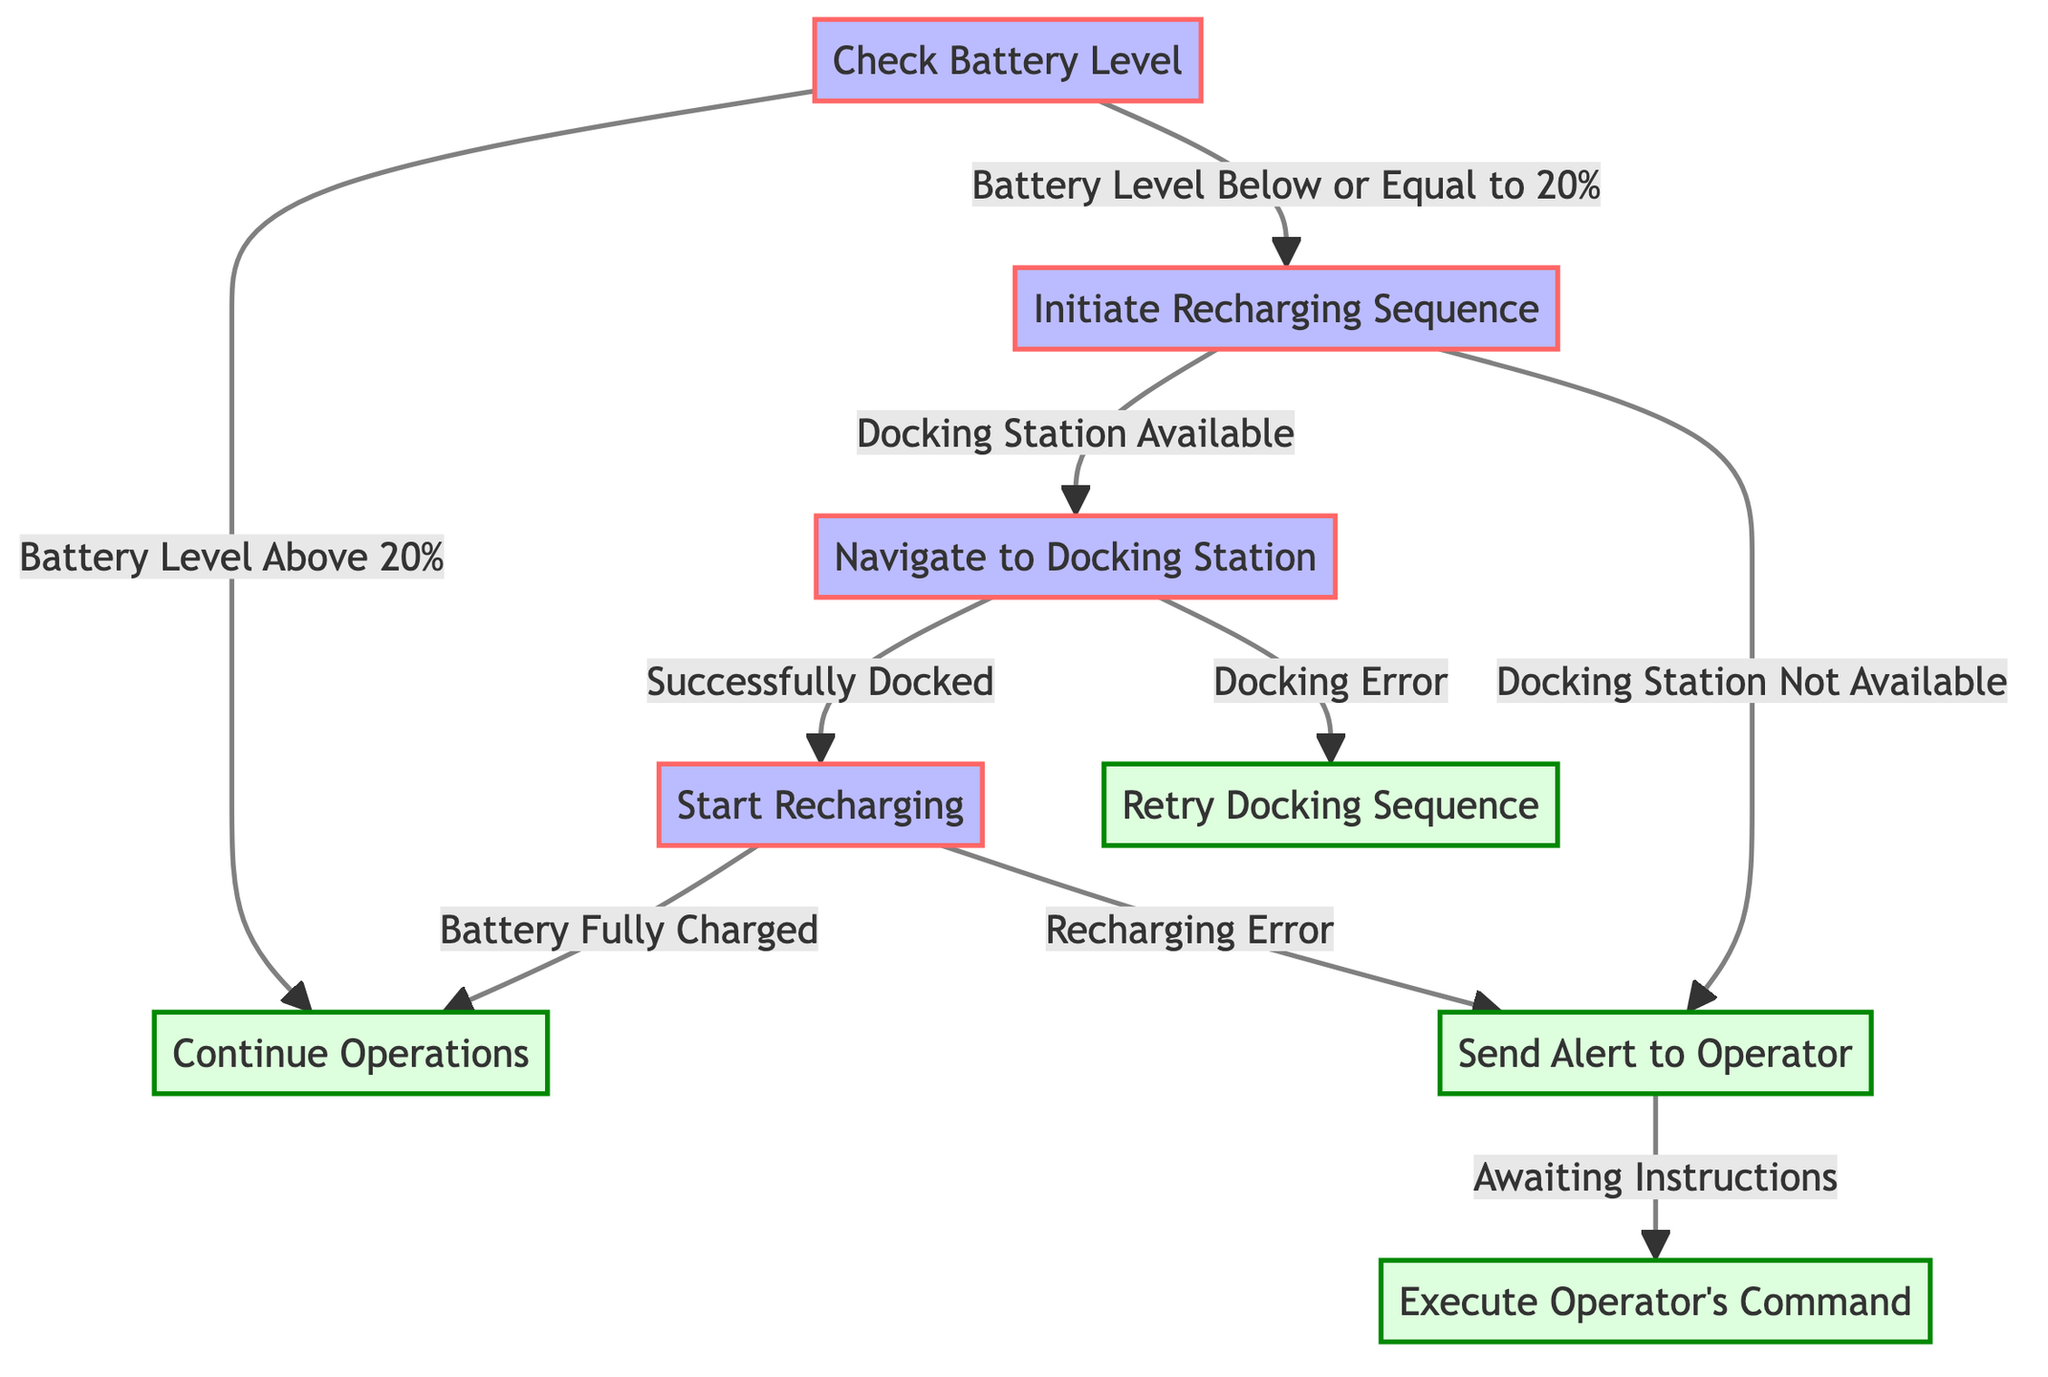What is the first step in the decision tree? The first step in the diagram is "Check Battery Level," which is indicated at the top of the flow.
Answer: Check Battery Level How many primary nodes are represented in the diagram? There are five primary steps or nodes present in the decision tree: Check Battery Level, Initiate Recharging Sequence, Navigate to Docking Station, Start Recharging, and Send Alert to Operator.
Answer: Five What happens if the battery level is above 20%? If the battery level is above 20%, the next step is to "Continue Operations," as shown in the first condition of the diagram.
Answer: Continue Operations What action does the robot take if the docking station is not available? If the docking station is not available, the robot will "Send Alert to Operator" as specified in one of the conditions from the Initiate Recharging Sequence step.
Answer: Send Alert to Operator What is the consequence of a recharging error? In the event of a recharging error, the robot will "Send Alert to Operator," as indicated in the flow from the Start Recharging node.
Answer: Send Alert to Operator What is the next step if there is a docking error? If there is a docking error, the robot will "Retry Docking Sequence," according to the conditions that flow from the Navigate to Docking Station step.
Answer: Retry Docking Sequence How does the decision tree respond when the battery is fully charged? When the battery is fully charged, the decision tree directs to "Continue Operations," showing a successful completion of the recharging process.
Answer: Continue Operations What is the endpoint if the robot is awaiting instructions after sending an alert? The endpoint in this case is "Execute Operator's Command," which is the next step after sending the alert and waiting for instructions.
Answer: Execute Operator's Command What step follows after checking the battery level? After checking the battery level, if the level is below or equal to 20%, the next step is "Initiate Recharging Sequence," leading to a response based on the conditions related to docking stations.
Answer: Initiate Recharging Sequence 